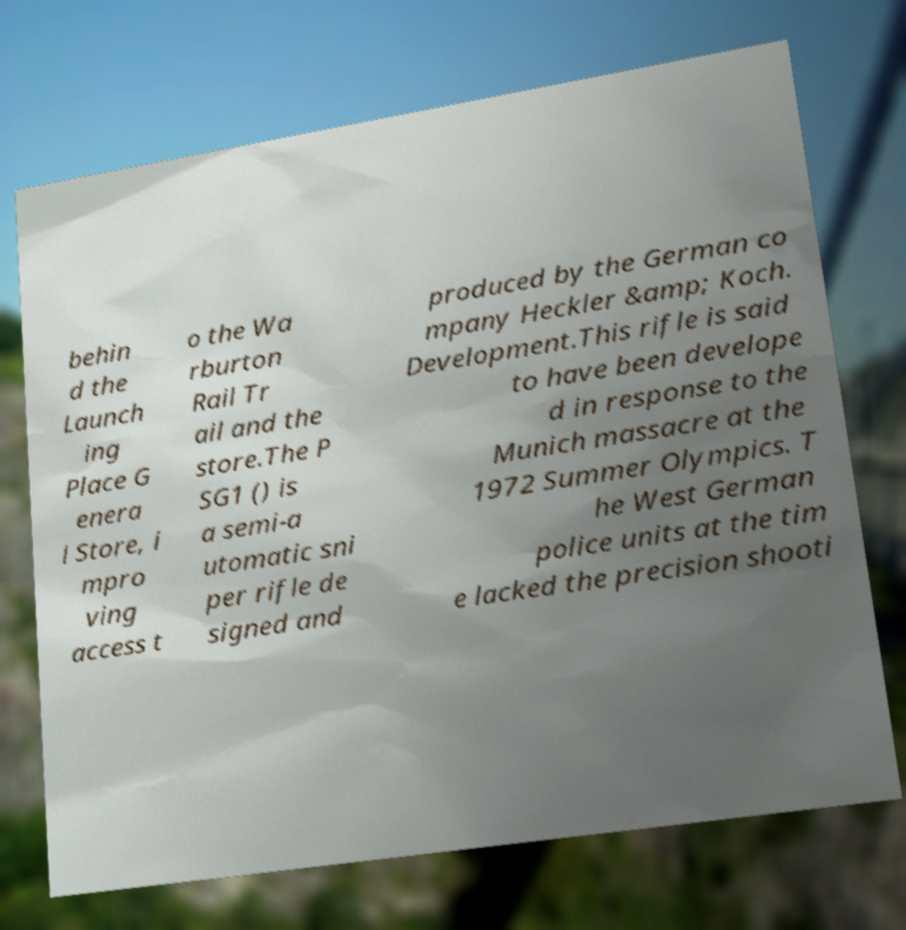What messages or text are displayed in this image? I need them in a readable, typed format. behin d the Launch ing Place G enera l Store, i mpro ving access t o the Wa rburton Rail Tr ail and the store.The P SG1 () is a semi-a utomatic sni per rifle de signed and produced by the German co mpany Heckler &amp; Koch. Development.This rifle is said to have been develope d in response to the Munich massacre at the 1972 Summer Olympics. T he West German police units at the tim e lacked the precision shooti 